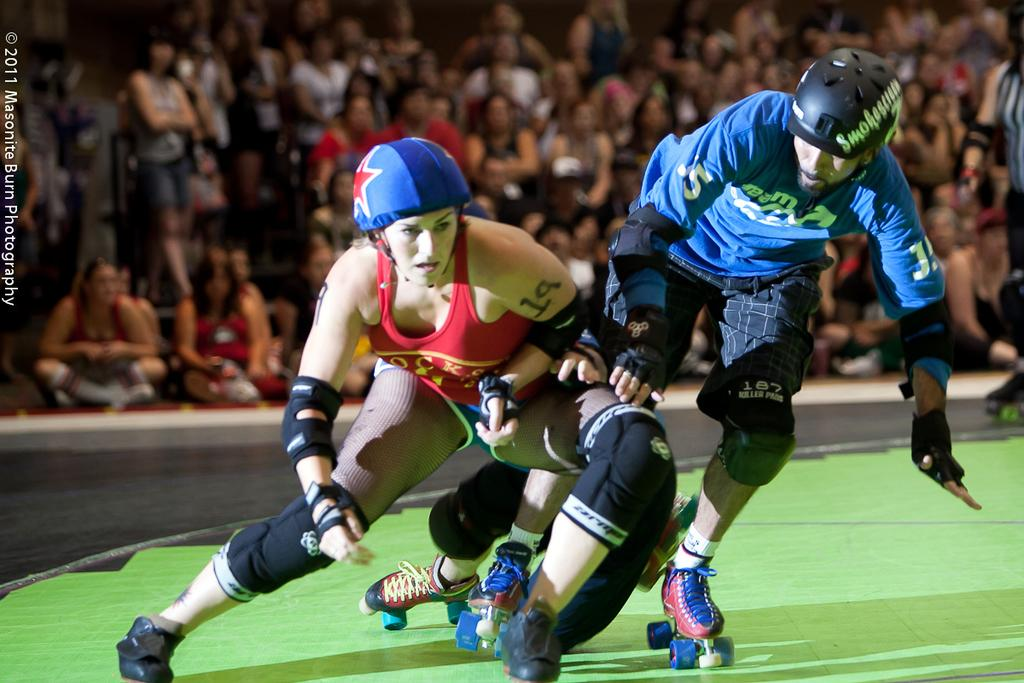What are the people in the foreground of the image doing? The people in the foreground of the image are skating. What are the people in the background of the image doing? The people in the background of the image are sitting. How many maids are present in the image, and what are they sorting? There are no maids present in the image, and no sorting is taking place. 